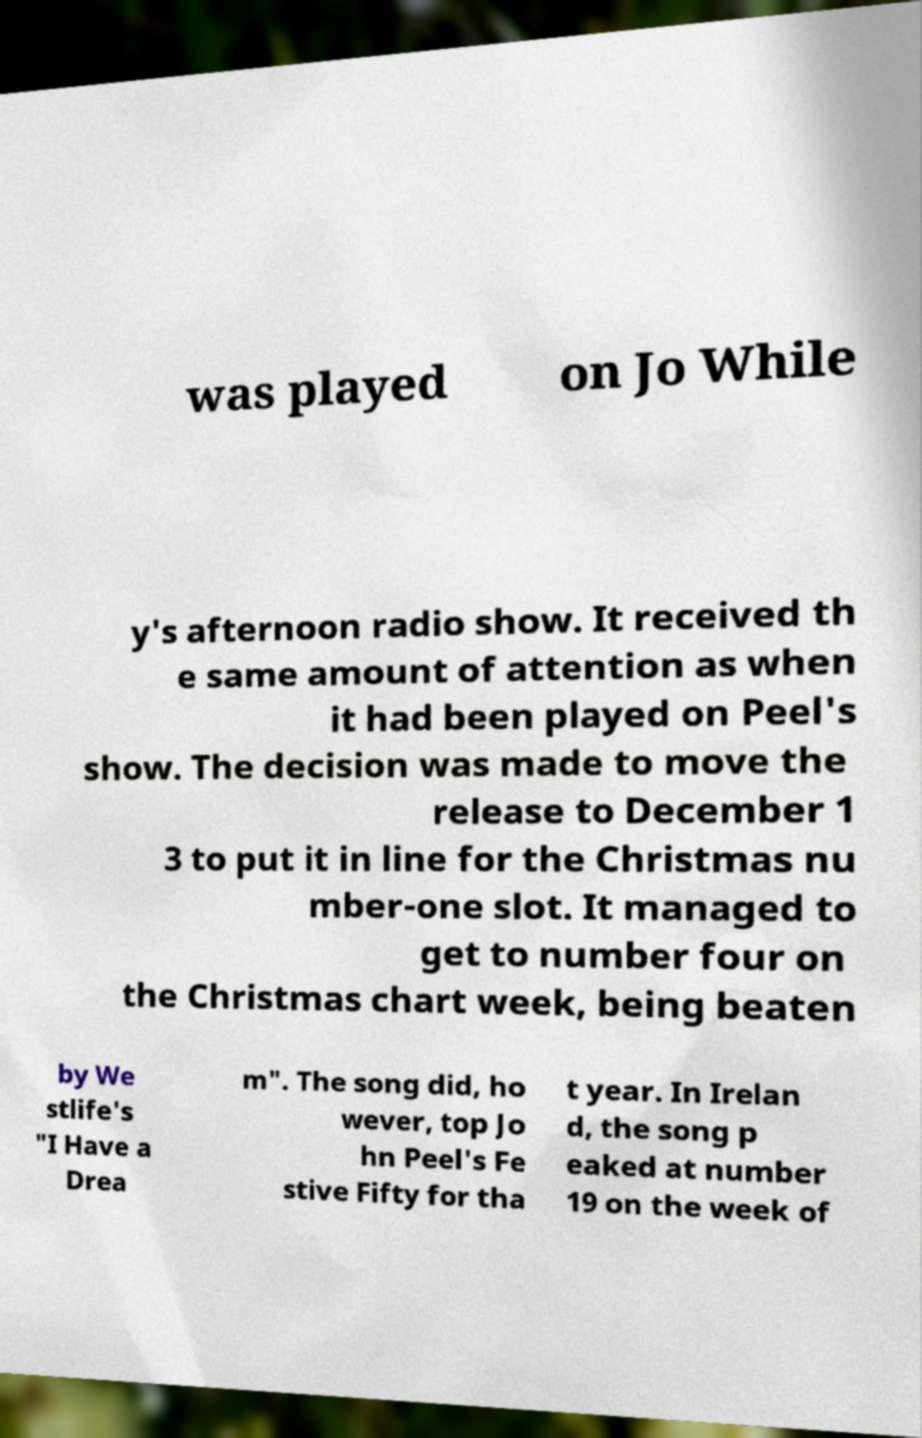Please read and relay the text visible in this image. What does it say? was played on Jo While y's afternoon radio show. It received th e same amount of attention as when it had been played on Peel's show. The decision was made to move the release to December 1 3 to put it in line for the Christmas nu mber-one slot. It managed to get to number four on the Christmas chart week, being beaten by We stlife's "I Have a Drea m". The song did, ho wever, top Jo hn Peel's Fe stive Fifty for tha t year. In Irelan d, the song p eaked at number 19 on the week of 